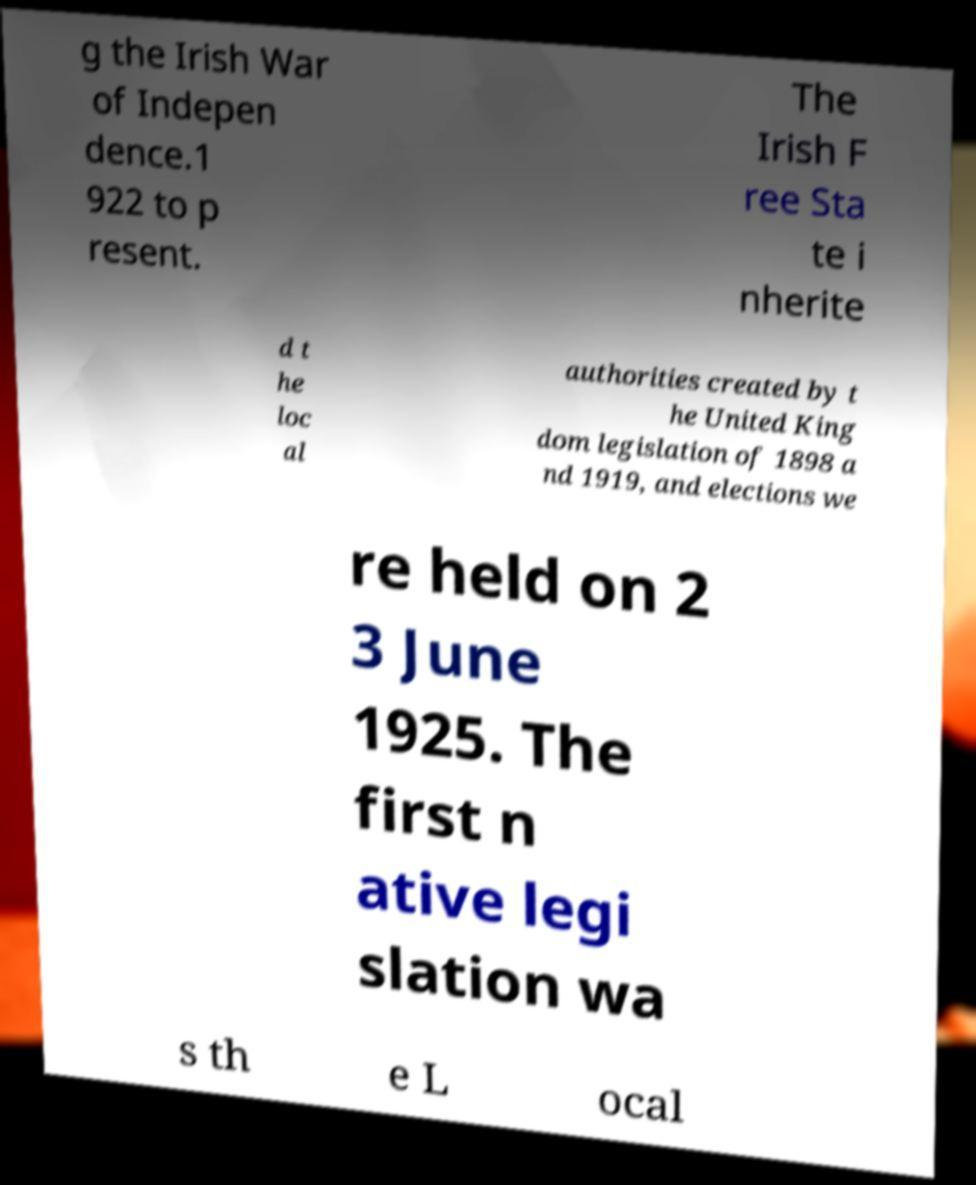Could you assist in decoding the text presented in this image and type it out clearly? g the Irish War of Indepen dence.1 922 to p resent. The Irish F ree Sta te i nherite d t he loc al authorities created by t he United King dom legislation of 1898 a nd 1919, and elections we re held on 2 3 June 1925. The first n ative legi slation wa s th e L ocal 